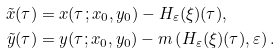<formula> <loc_0><loc_0><loc_500><loc_500>\tilde { x } ( \tau ) & = x ( \tau ; x _ { 0 } , y _ { 0 } ) - H _ { \varepsilon } ( \xi ) ( \tau ) , \\ \tilde { y } ( \tau ) & = y ( \tau ; x _ { 0 } , y _ { 0 } ) - m \left ( H _ { \varepsilon } ( \xi ) ( \tau ) , \varepsilon \right ) .</formula> 